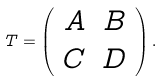Convert formula to latex. <formula><loc_0><loc_0><loc_500><loc_500>T = \left ( \begin{array} { c c } { A } & { B } \\ { C } & { D } \end{array} \right ) .</formula> 